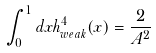<formula> <loc_0><loc_0><loc_500><loc_500>\int _ { 0 } ^ { 1 } d x h _ { w e a k } ^ { 4 } ( x ) = \frac { 2 } { A ^ { 2 } }</formula> 